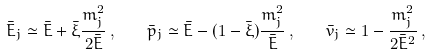<formula> <loc_0><loc_0><loc_500><loc_500>\bar { E } _ { j } \simeq \bar { E } + \bar { \xi } \frac { m _ { j } ^ { 2 } } { 2 \bar { E } } \, , \quad \bar { p } _ { j } \simeq \bar { E } - ( 1 - \bar { \xi } ) \frac { m _ { j } ^ { 2 } } { \bar { E } } \, , \quad \bar { v } _ { j } \simeq 1 - \frac { m _ { j } ^ { 2 } } { 2 \bar { E } ^ { 2 } } \, ,</formula> 